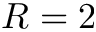<formula> <loc_0><loc_0><loc_500><loc_500>R = 2</formula> 